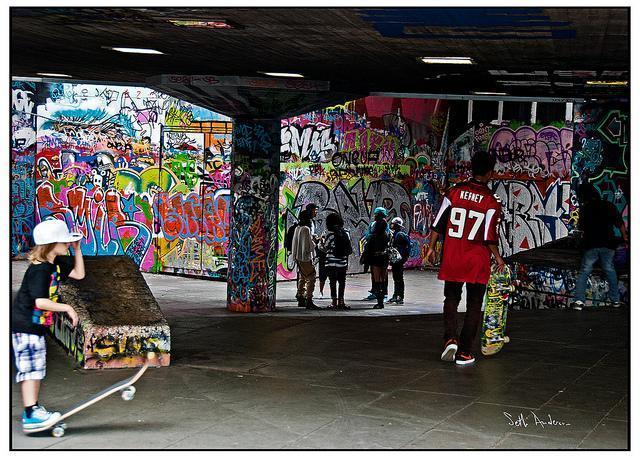How many wheels are on the skateboard?
Give a very brief answer. 4. How many people are in the photo?
Give a very brief answer. 4. 